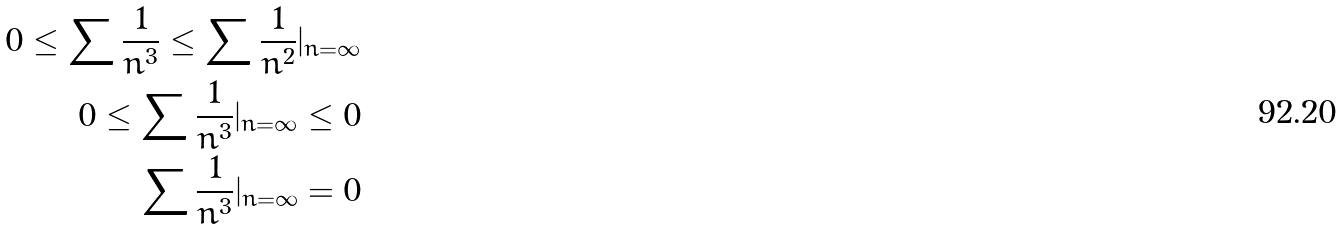<formula> <loc_0><loc_0><loc_500><loc_500>0 \leq \sum \frac { 1 } { n ^ { 3 } } \leq \sum \frac { 1 } { n ^ { 2 } } | _ { n = \infty } \\ 0 \leq \sum \frac { 1 } { n ^ { 3 } } | _ { n = \infty } \leq 0 \\ \sum \frac { 1 } { n ^ { 3 } } | _ { n = \infty } = 0</formula> 